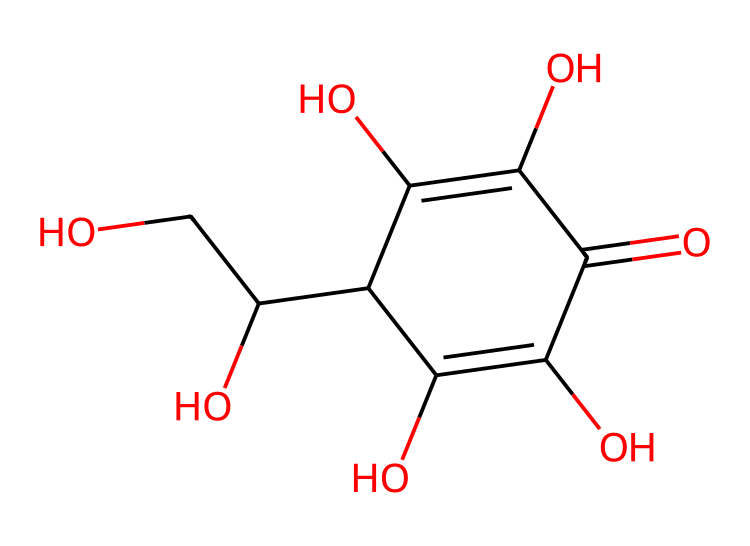What is the molecular formula of vitamin C? The SMILES representation can be translated to identify the types and quantities of atoms present. Counting the carbons (C), hydrogens (H), and oxygens (O) gives the molecular formula C6H8O6.
Answer: C6H8O6 How many hydroxyl (-OH) groups are present in the structure? The structure contains multiple -OH groups. By examining the SMILES, we can see that there are four -OH groups in total within the compound.
Answer: 4 Does vitamin C have any rings in its structure? By analyzing the SMILES, we observe that there is a cyclic structure present, as indicated by the 'C1' notation which starts a ring and the matching 'C1' closing it, confirming that it has one ring.
Answer: yes What type of functional groups are predominant in vitamin C? The structure of vitamin C consists primarily of hydroxyl (-OH) groups and carboxylic acid (–COOH) groups which are indicative of its properties as a vitamin.
Answer: hydroxyl and carboxylic acid Is vitamin C a water-soluble vitamin? Given the presence of multiple hydroxyl groups in its structure, which allows for hydrogen bonding with water, vitamin C is classified as a water-soluble vitamin.
Answer: yes What is the significance of the carbonyl (C=O) group in vitamin C? The carbonyl group is crucial for the reactivity of vitamin C, contributing to its antioxidant properties by allowing it to participate in redox reactions.
Answer: antioxidant properties 